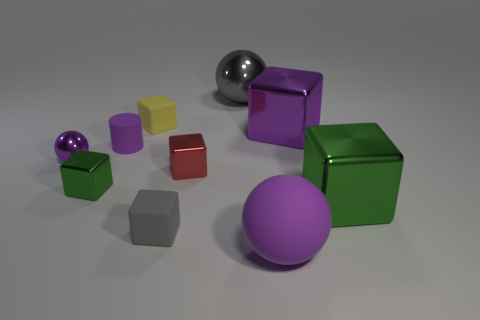Subtract all big gray metal balls. How many balls are left? 2 Subtract all blue balls. How many green blocks are left? 2 Subtract 1 spheres. How many spheres are left? 2 Subtract all yellow cubes. How many cubes are left? 5 Subtract all cubes. How many objects are left? 4 Subtract all green spheres. Subtract all blue cylinders. How many spheres are left? 3 Subtract all large brown matte cylinders. Subtract all tiny red objects. How many objects are left? 9 Add 8 tiny green things. How many tiny green things are left? 9 Add 6 gray matte things. How many gray matte things exist? 7 Subtract 0 cyan cylinders. How many objects are left? 10 